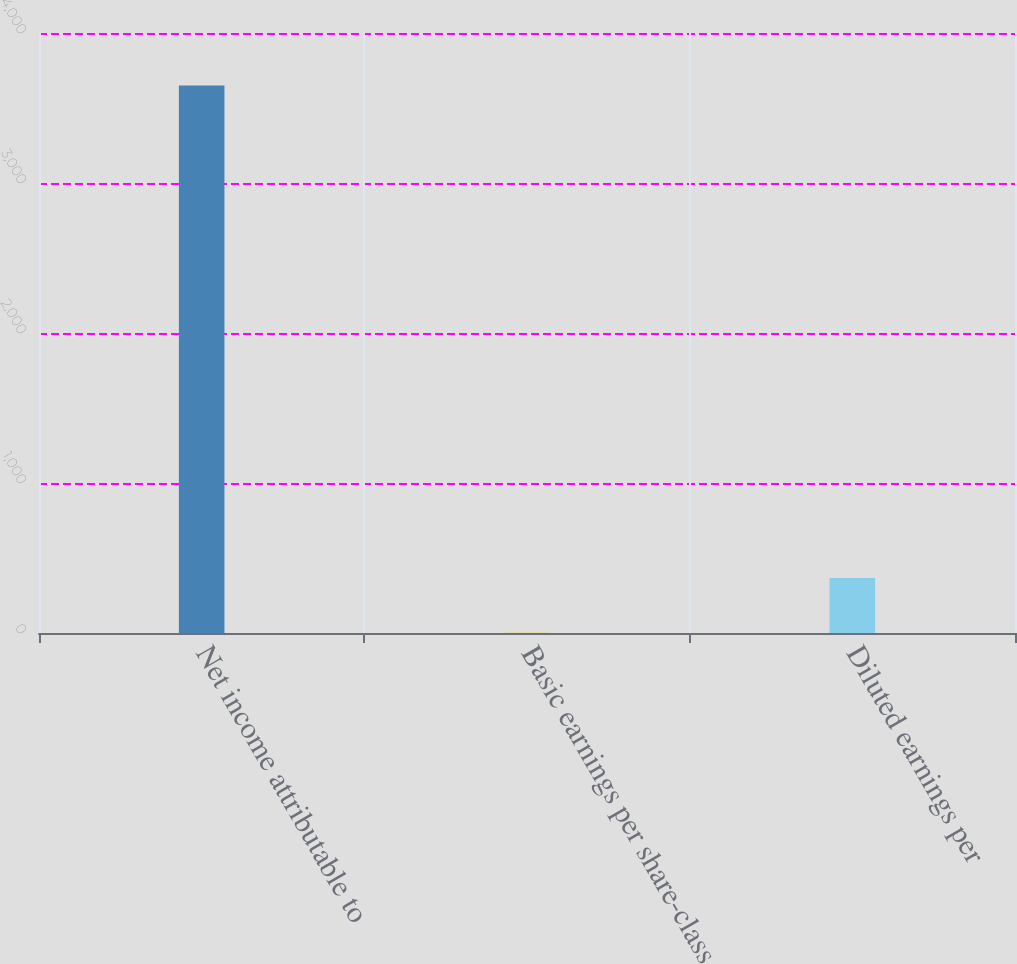<chart> <loc_0><loc_0><loc_500><loc_500><bar_chart><fcel>Net income attributable to<fcel>Basic earnings per share-class<fcel>Diluted earnings per<nl><fcel>3650<fcel>1.29<fcel>366.16<nl></chart> 